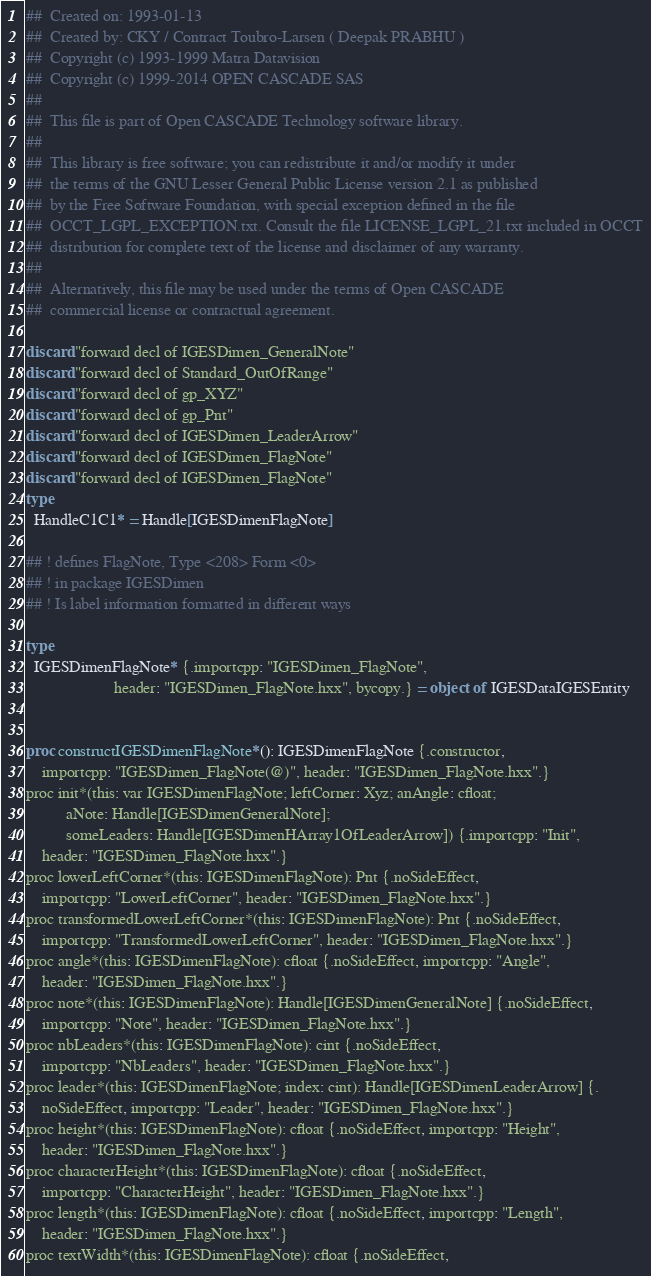<code> <loc_0><loc_0><loc_500><loc_500><_Nim_>##  Created on: 1993-01-13
##  Created by: CKY / Contract Toubro-Larsen ( Deepak PRABHU )
##  Copyright (c) 1993-1999 Matra Datavision
##  Copyright (c) 1999-2014 OPEN CASCADE SAS
##
##  This file is part of Open CASCADE Technology software library.
##
##  This library is free software; you can redistribute it and/or modify it under
##  the terms of the GNU Lesser General Public License version 2.1 as published
##  by the Free Software Foundation, with special exception defined in the file
##  OCCT_LGPL_EXCEPTION.txt. Consult the file LICENSE_LGPL_21.txt included in OCCT
##  distribution for complete text of the license and disclaimer of any warranty.
##
##  Alternatively, this file may be used under the terms of Open CASCADE
##  commercial license or contractual agreement.

discard "forward decl of IGESDimen_GeneralNote"
discard "forward decl of Standard_OutOfRange"
discard "forward decl of gp_XYZ"
discard "forward decl of gp_Pnt"
discard "forward decl of IGESDimen_LeaderArrow"
discard "forward decl of IGESDimen_FlagNote"
discard "forward decl of IGESDimen_FlagNote"
type
  HandleC1C1* = Handle[IGESDimenFlagNote]

## ! defines FlagNote, Type <208> Form <0>
## ! in package IGESDimen
## ! Is label information formatted in different ways

type
  IGESDimenFlagNote* {.importcpp: "IGESDimen_FlagNote",
                      header: "IGESDimen_FlagNote.hxx", bycopy.} = object of IGESDataIGESEntity


proc constructIGESDimenFlagNote*(): IGESDimenFlagNote {.constructor,
    importcpp: "IGESDimen_FlagNote(@)", header: "IGESDimen_FlagNote.hxx".}
proc init*(this: var IGESDimenFlagNote; leftCorner: Xyz; anAngle: cfloat;
          aNote: Handle[IGESDimenGeneralNote];
          someLeaders: Handle[IGESDimenHArray1OfLeaderArrow]) {.importcpp: "Init",
    header: "IGESDimen_FlagNote.hxx".}
proc lowerLeftCorner*(this: IGESDimenFlagNote): Pnt {.noSideEffect,
    importcpp: "LowerLeftCorner", header: "IGESDimen_FlagNote.hxx".}
proc transformedLowerLeftCorner*(this: IGESDimenFlagNote): Pnt {.noSideEffect,
    importcpp: "TransformedLowerLeftCorner", header: "IGESDimen_FlagNote.hxx".}
proc angle*(this: IGESDimenFlagNote): cfloat {.noSideEffect, importcpp: "Angle",
    header: "IGESDimen_FlagNote.hxx".}
proc note*(this: IGESDimenFlagNote): Handle[IGESDimenGeneralNote] {.noSideEffect,
    importcpp: "Note", header: "IGESDimen_FlagNote.hxx".}
proc nbLeaders*(this: IGESDimenFlagNote): cint {.noSideEffect,
    importcpp: "NbLeaders", header: "IGESDimen_FlagNote.hxx".}
proc leader*(this: IGESDimenFlagNote; index: cint): Handle[IGESDimenLeaderArrow] {.
    noSideEffect, importcpp: "Leader", header: "IGESDimen_FlagNote.hxx".}
proc height*(this: IGESDimenFlagNote): cfloat {.noSideEffect, importcpp: "Height",
    header: "IGESDimen_FlagNote.hxx".}
proc characterHeight*(this: IGESDimenFlagNote): cfloat {.noSideEffect,
    importcpp: "CharacterHeight", header: "IGESDimen_FlagNote.hxx".}
proc length*(this: IGESDimenFlagNote): cfloat {.noSideEffect, importcpp: "Length",
    header: "IGESDimen_FlagNote.hxx".}
proc textWidth*(this: IGESDimenFlagNote): cfloat {.noSideEffect,</code> 